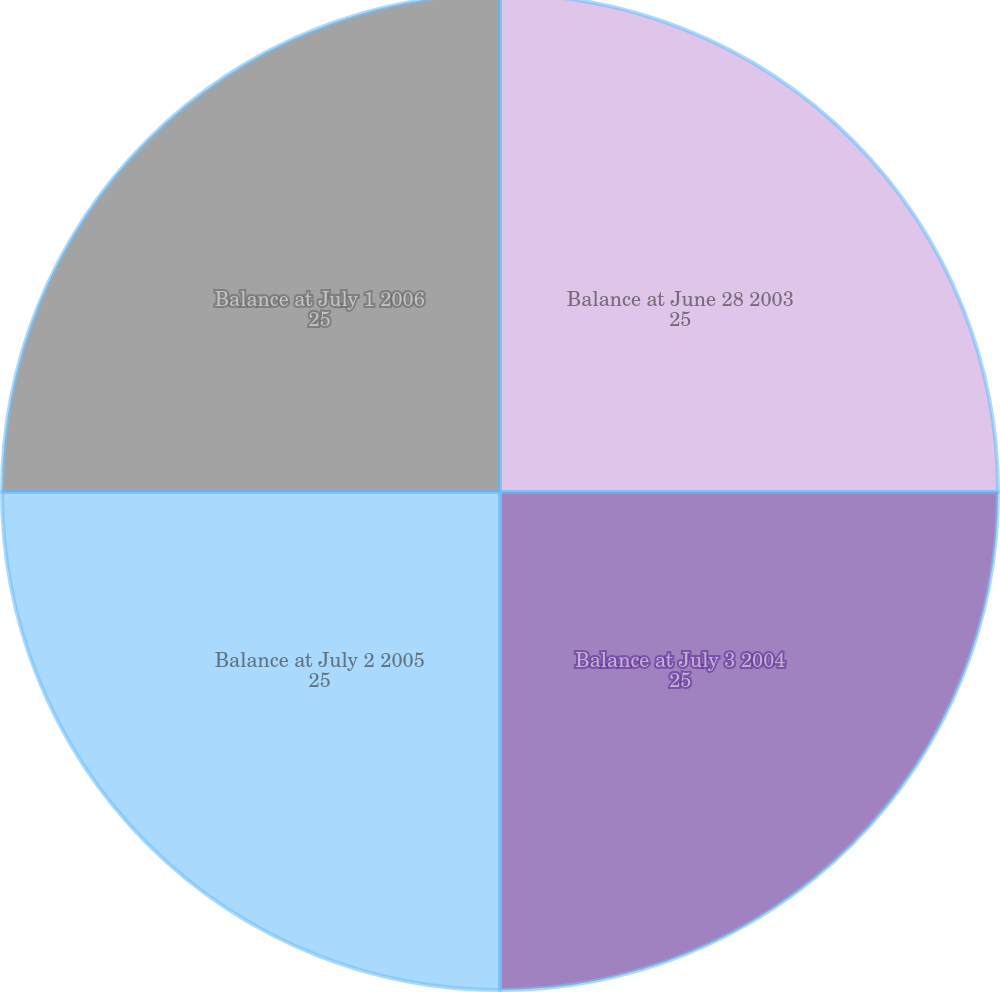<chart> <loc_0><loc_0><loc_500><loc_500><pie_chart><fcel>Balance at June 28 2003<fcel>Balance at July 3 2004<fcel>Balance at July 2 2005<fcel>Balance at July 1 2006<nl><fcel>25.0%<fcel>25.0%<fcel>25.0%<fcel>25.0%<nl></chart> 